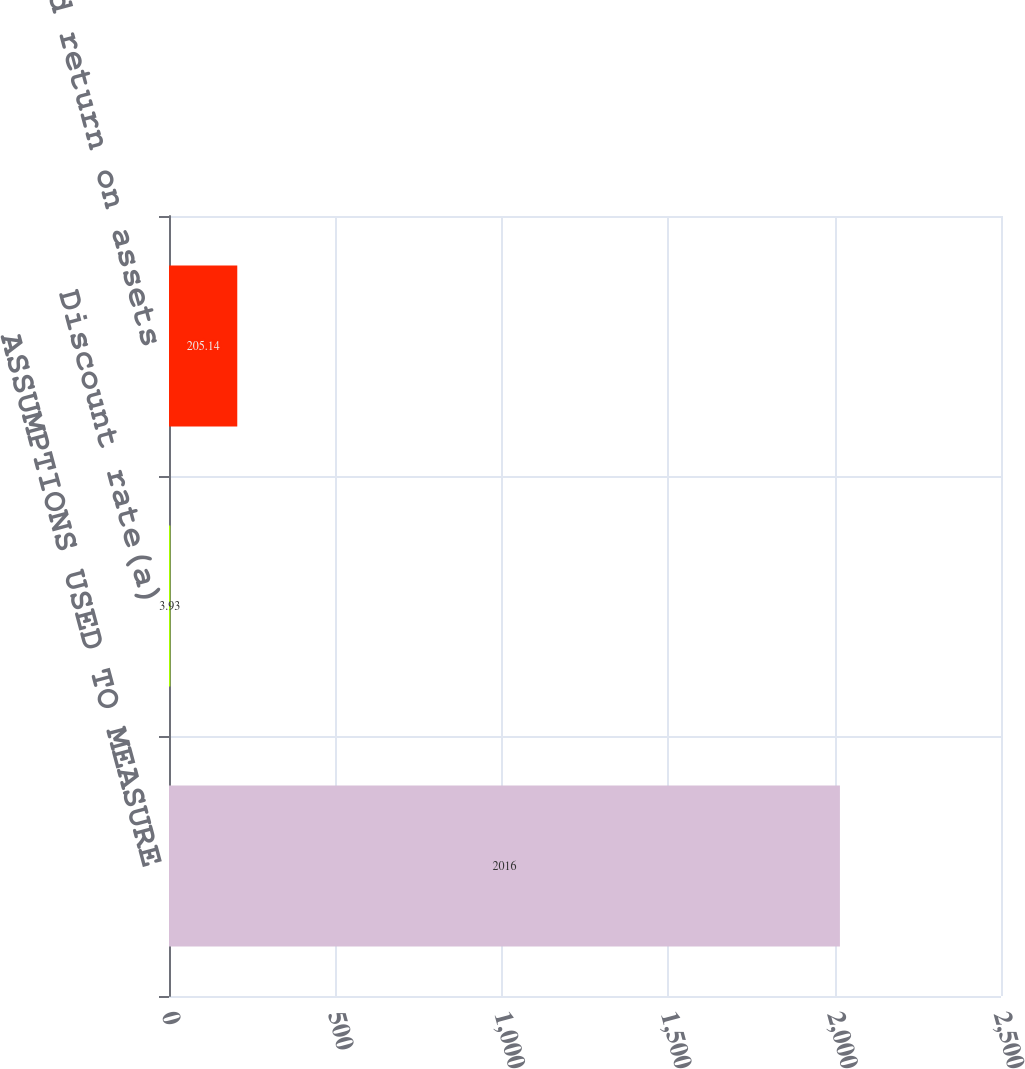Convert chart. <chart><loc_0><loc_0><loc_500><loc_500><bar_chart><fcel>ASSUMPTIONS USED TO MEASURE<fcel>Discount rate(a)<fcel>Expected return on assets<nl><fcel>2016<fcel>3.93<fcel>205.14<nl></chart> 